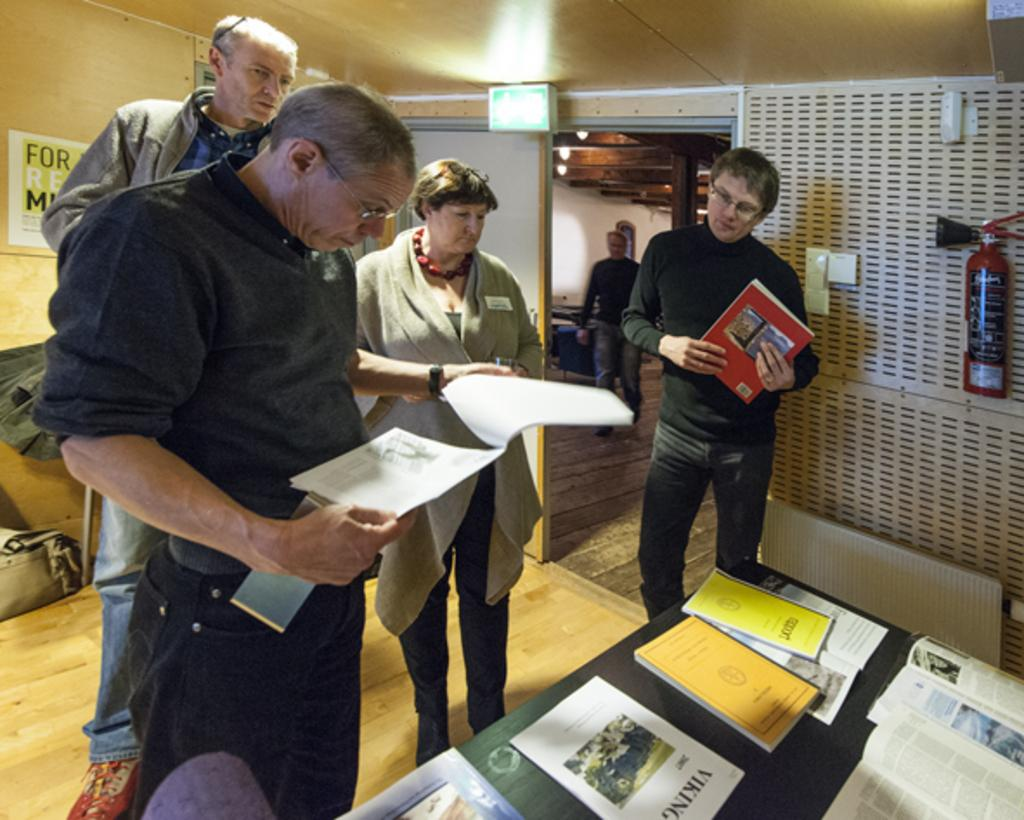<image>
Render a clear and concise summary of the photo. men standing around a table reading about the vikings 